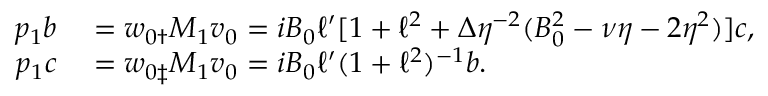Convert formula to latex. <formula><loc_0><loc_0><loc_500><loc_500>\begin{array} { r l } { p _ { 1 } b } & = w _ { 0 \dag } M _ { 1 } v _ { 0 } = i B _ { 0 } \ell ^ { \prime } [ 1 + \ell ^ { 2 } + \Delta \eta ^ { - 2 } ( B _ { 0 } ^ { 2 } - \nu \eta - 2 \eta ^ { 2 } ) ] c , } \\ { p _ { 1 } c } & = w _ { 0 \ddag } M _ { 1 } v _ { 0 } = i B _ { 0 } \ell ^ { \prime } ( 1 + \ell ^ { 2 } ) ^ { - 1 } b . } \end{array}</formula> 